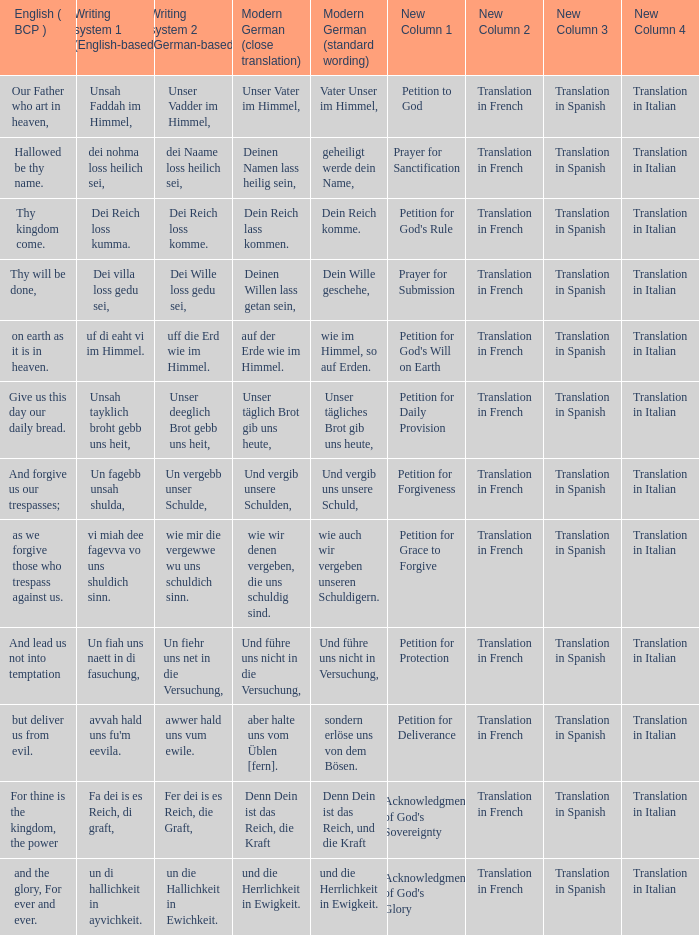What is the english (bcp) phrase "for thine is the kingdom, the power" in modern german with standard wording? Denn Dein ist das Reich, und die Kraft. 